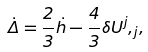<formula> <loc_0><loc_0><loc_500><loc_500>\dot { \Delta } = \frac { 2 } { 3 } \dot { h } - \frac { 4 } { 3 } \delta { U ^ { j } , _ { j } } ,</formula> 